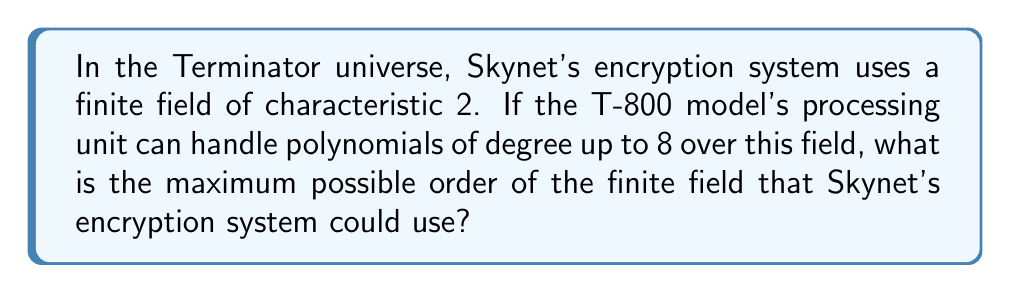Give your solution to this math problem. Let's approach this step-by-step:

1) In a finite field of characteristic 2, the order is always a power of 2. We can represent this as $2^n$, where $n$ is a positive integer.

2) The T-800 model can handle polynomials of degree up to 8. This means that the field can be constructed using an irreducible polynomial of degree at most 8 over the base field $\mathbb{F}_2$.

3) In general, if we have an irreducible polynomial of degree $m$ over $\mathbb{F}_2$, it generates a field of order $2^m$.

4) Given that the maximum degree of the polynomial is 8, the largest possible field would be generated by an irreducible polynomial of degree 8.

5) Therefore, the maximum order of the field would be:

   $$2^8 = 256$$

This means that Skynet's encryption system could use a finite field with a maximum of 256 elements, given the T-800's processing capabilities.
Answer: $256$ 